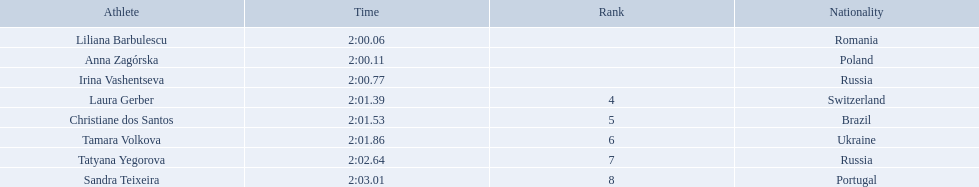What were all the finishing times? 2:00.06, 2:00.11, 2:00.77, 2:01.39, 2:01.53, 2:01.86, 2:02.64, 2:03.01. Can you parse all the data within this table? {'header': ['Athlete', 'Time', 'Rank', 'Nationality'], 'rows': [['Liliana Barbulescu', '2:00.06', '', 'Romania'], ['Anna Zagórska', '2:00.11', '', 'Poland'], ['Irina Vashentseva', '2:00.77', '', 'Russia'], ['Laura Gerber', '2:01.39', '4', 'Switzerland'], ['Christiane dos Santos', '2:01.53', '5', 'Brazil'], ['Tamara Volkova', '2:01.86', '6', 'Ukraine'], ['Tatyana Yegorova', '2:02.64', '7', 'Russia'], ['Sandra Teixeira', '2:03.01', '8', 'Portugal']]} Which of these is anna zagorska's? 2:00.11. 